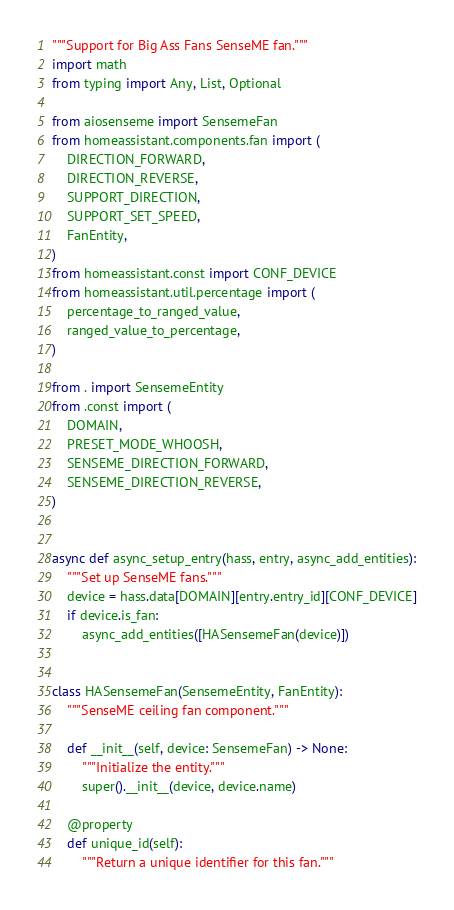<code> <loc_0><loc_0><loc_500><loc_500><_Python_>"""Support for Big Ass Fans SenseME fan."""
import math
from typing import Any, List, Optional

from aiosenseme import SensemeFan
from homeassistant.components.fan import (
    DIRECTION_FORWARD,
    DIRECTION_REVERSE,
    SUPPORT_DIRECTION,
    SUPPORT_SET_SPEED,
    FanEntity,
)
from homeassistant.const import CONF_DEVICE
from homeassistant.util.percentage import (
    percentage_to_ranged_value,
    ranged_value_to_percentage,
)

from . import SensemeEntity
from .const import (
    DOMAIN,
    PRESET_MODE_WHOOSH,
    SENSEME_DIRECTION_FORWARD,
    SENSEME_DIRECTION_REVERSE,
)


async def async_setup_entry(hass, entry, async_add_entities):
    """Set up SenseME fans."""
    device = hass.data[DOMAIN][entry.entry_id][CONF_DEVICE]
    if device.is_fan:
        async_add_entities([HASensemeFan(device)])


class HASensemeFan(SensemeEntity, FanEntity):
    """SenseME ceiling fan component."""

    def __init__(self, device: SensemeFan) -> None:
        """Initialize the entity."""
        super().__init__(device, device.name)

    @property
    def unique_id(self):
        """Return a unique identifier for this fan."""</code> 